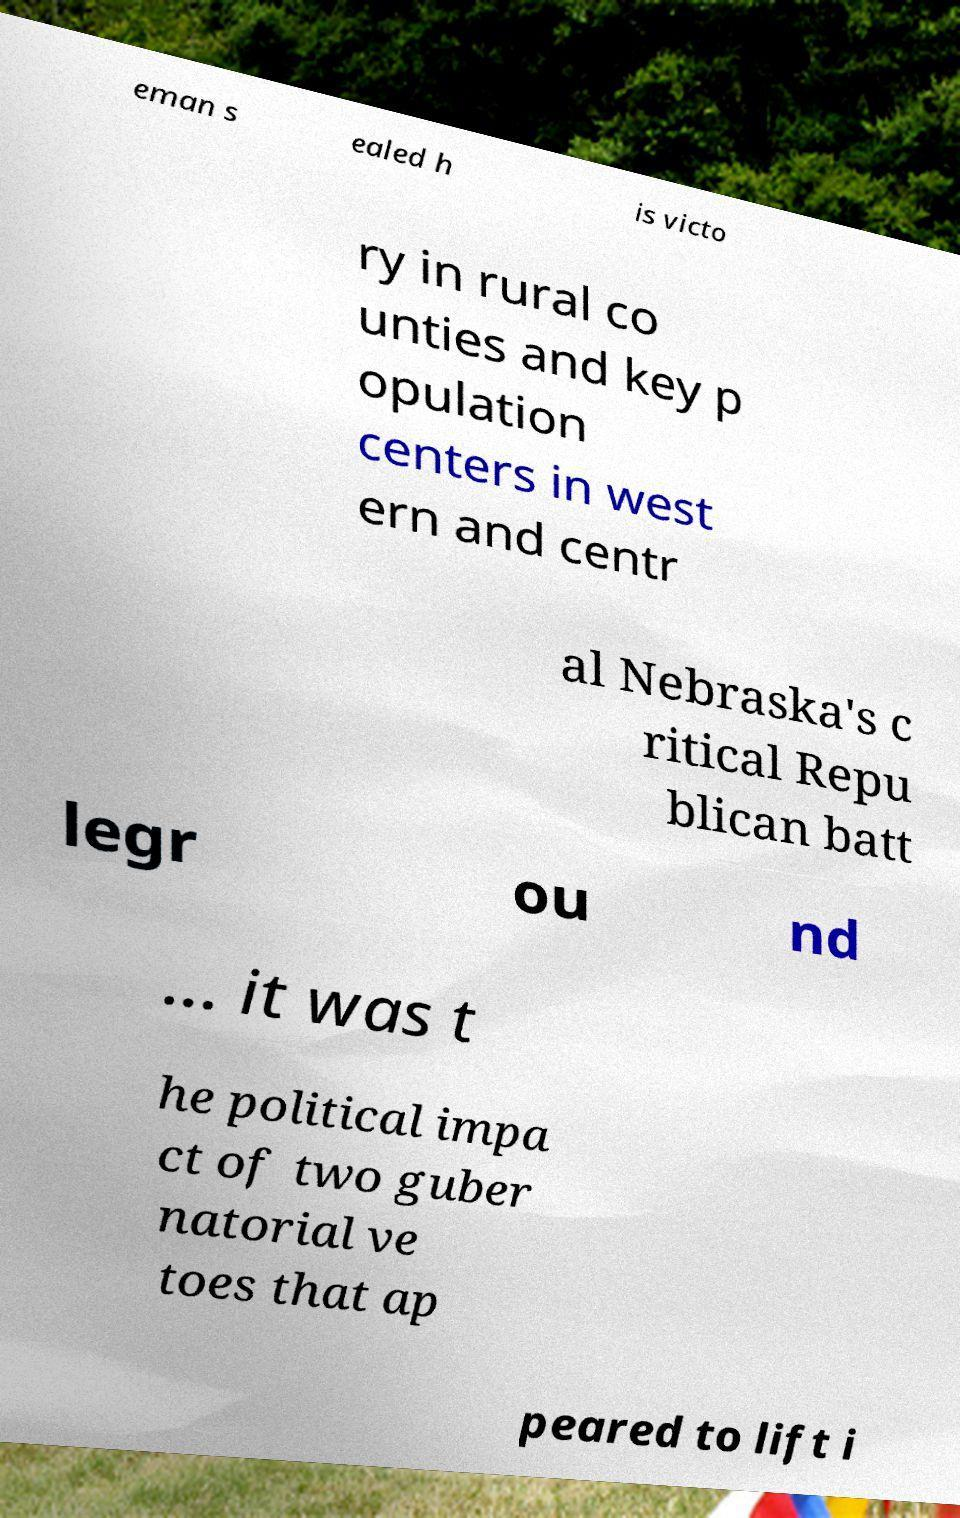What messages or text are displayed in this image? I need them in a readable, typed format. eman s ealed h is victo ry in rural co unties and key p opulation centers in west ern and centr al Nebraska's c ritical Repu blican batt legr ou nd ... it was t he political impa ct of two guber natorial ve toes that ap peared to lift i 